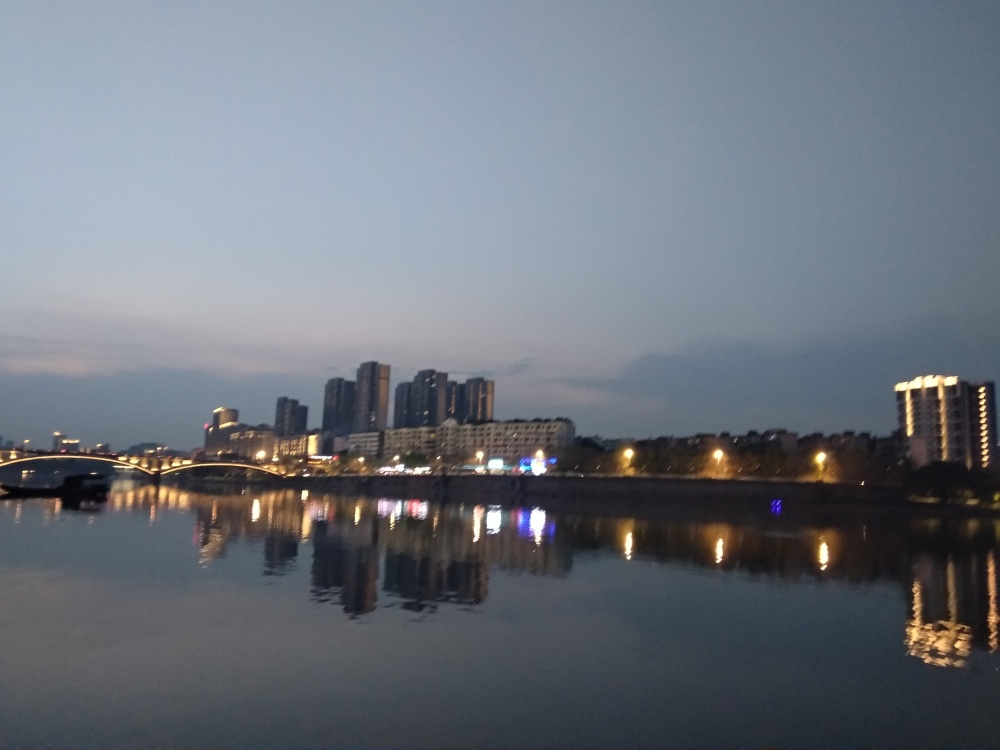Is the quality of this image acceptable?
A. No
B. Yes
Answer with the option's letter from the given choices directly.
 B. 